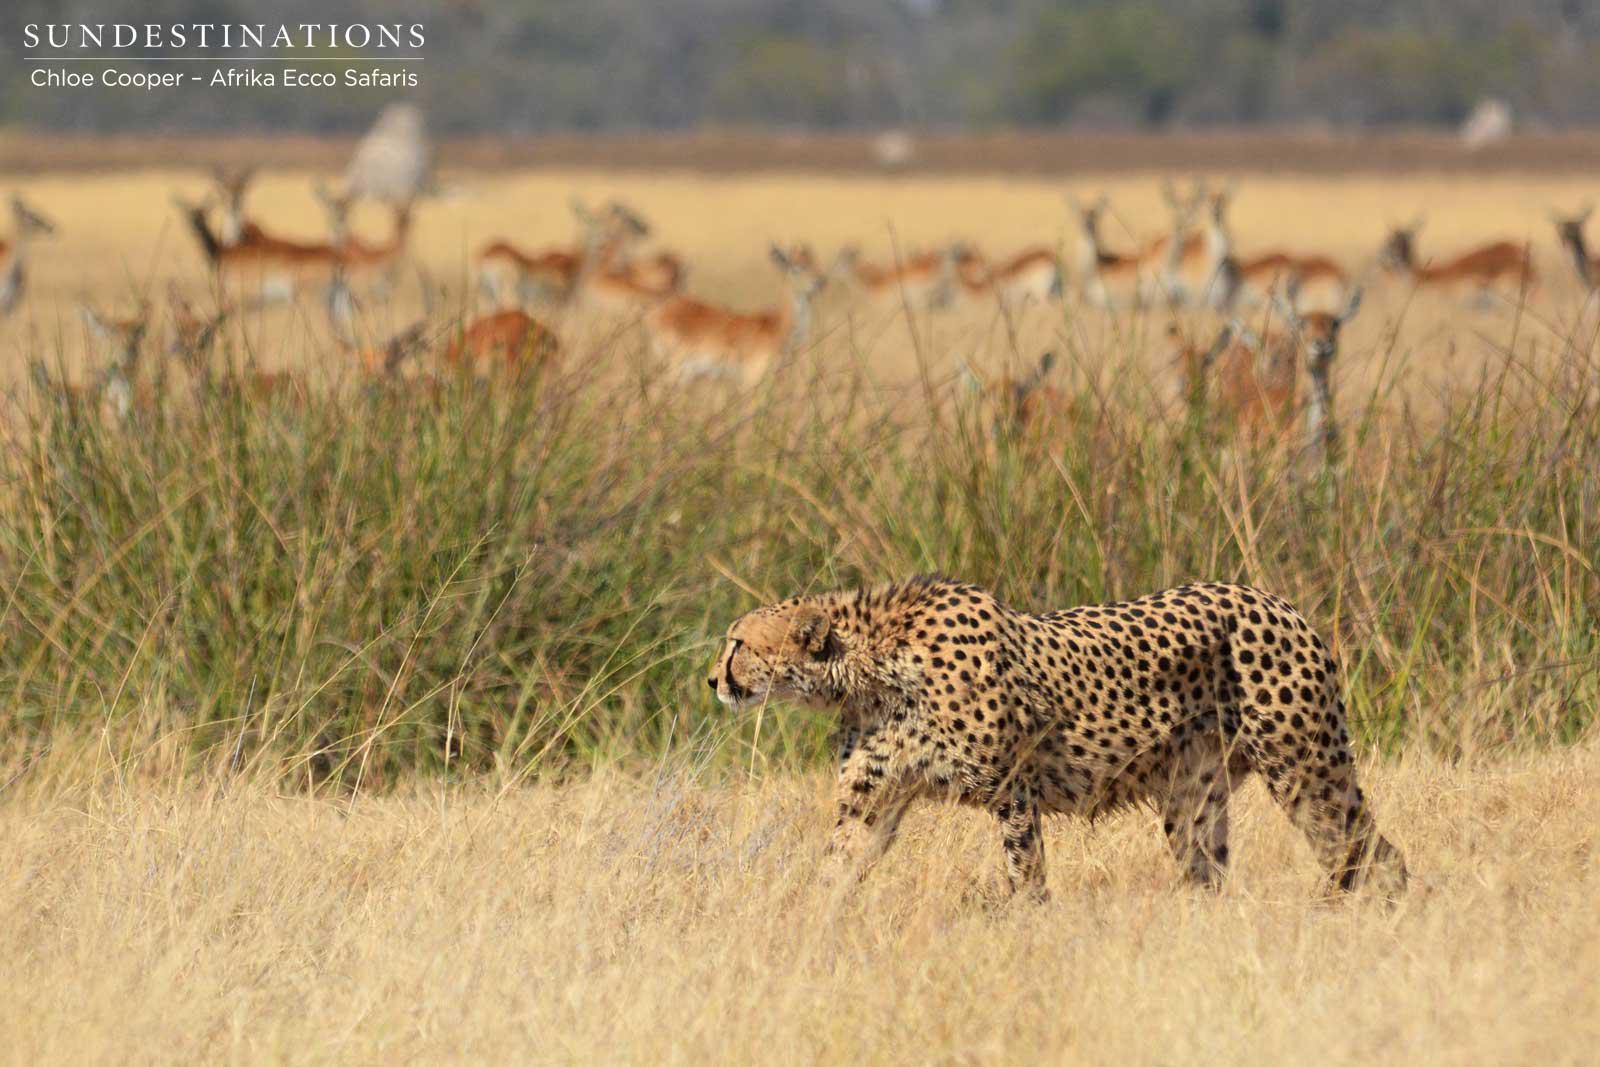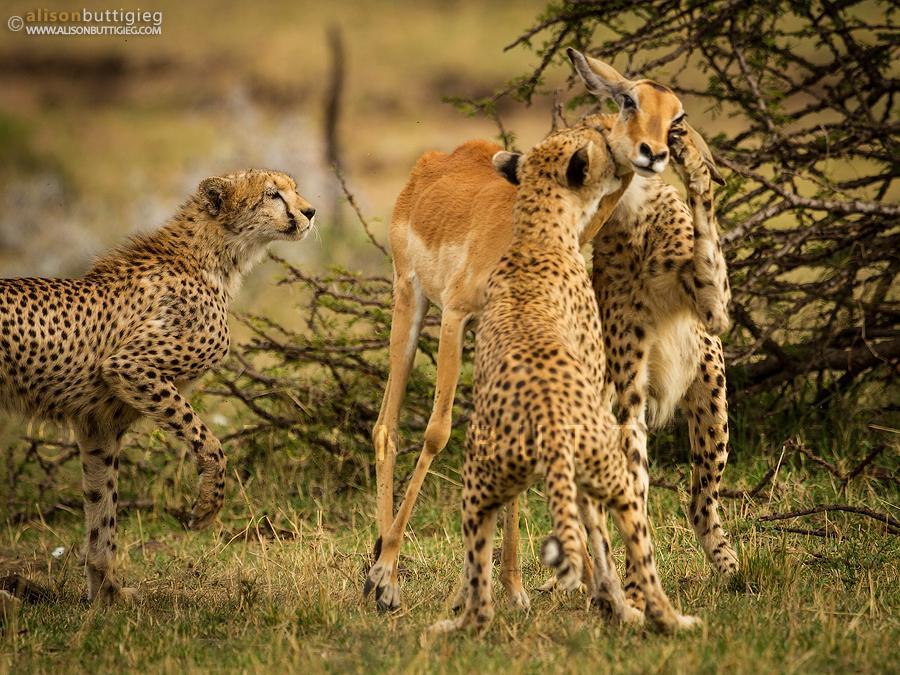The first image is the image on the left, the second image is the image on the right. Analyze the images presented: Is the assertion "Prey animals are visible in the background of the left image." valid? Answer yes or no. Yes. The first image is the image on the left, the second image is the image on the right. Considering the images on both sides, is "Two cheetahs are running." valid? Answer yes or no. No. 